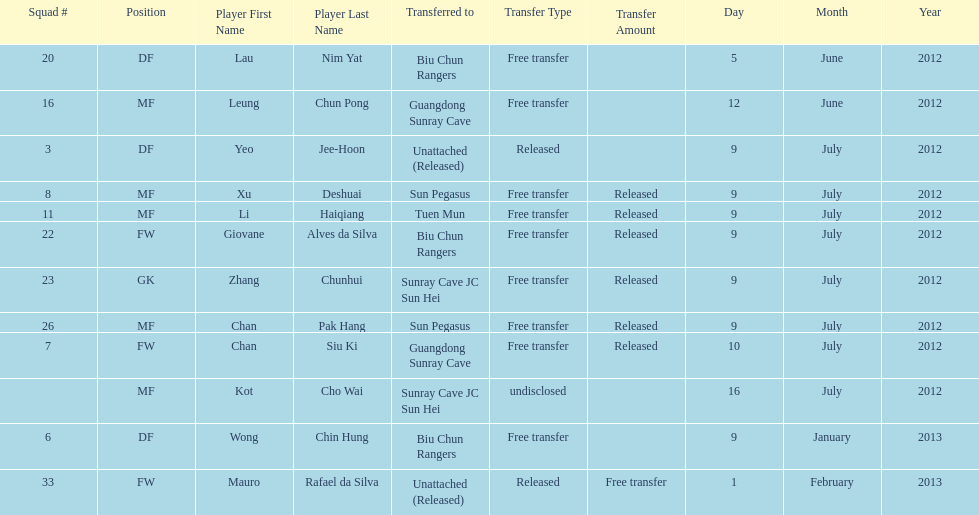What squad # is listed previous to squad # 7? 26. 